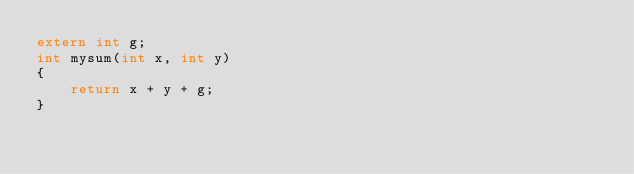<code> <loc_0><loc_0><loc_500><loc_500><_C_>extern int g;
int mysum(int x, int y)
{
    return x + y + g;
}</code> 